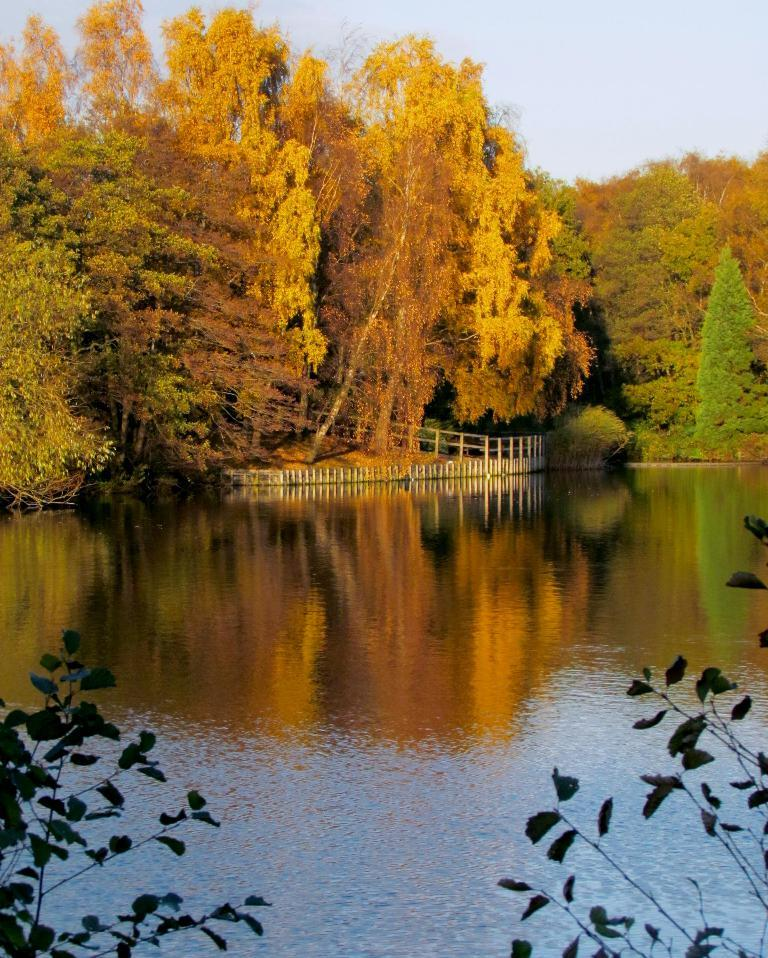What type of natural feature can be seen in the image? There is a river in the image. What is the primary element visible in the image? There is water visible in the image. What type of vegetation can be seen in the image? There are plants and trees in the image. What is visible in the background of the image? The sky is visible in the image. How would you describe the weather in the image? The sky is cloudy, and the color of the sky is white, which suggests a cloudy or overcast day. What type of circle can be seen in the image? There is no circle present in the image. What type of line is visible in the image? There is no line present in the image. 